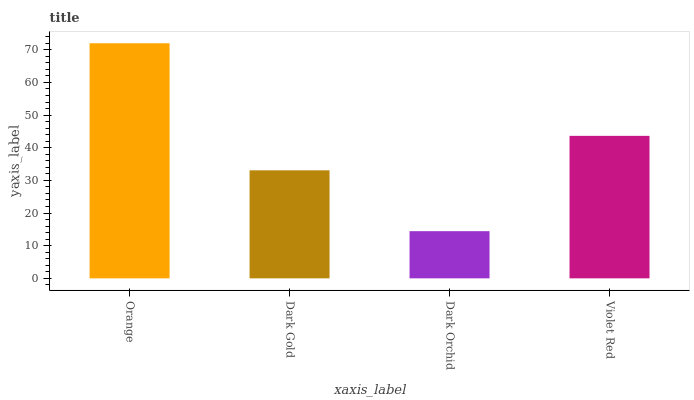Is Dark Gold the minimum?
Answer yes or no. No. Is Dark Gold the maximum?
Answer yes or no. No. Is Orange greater than Dark Gold?
Answer yes or no. Yes. Is Dark Gold less than Orange?
Answer yes or no. Yes. Is Dark Gold greater than Orange?
Answer yes or no. No. Is Orange less than Dark Gold?
Answer yes or no. No. Is Violet Red the high median?
Answer yes or no. Yes. Is Dark Gold the low median?
Answer yes or no. Yes. Is Dark Orchid the high median?
Answer yes or no. No. Is Orange the low median?
Answer yes or no. No. 